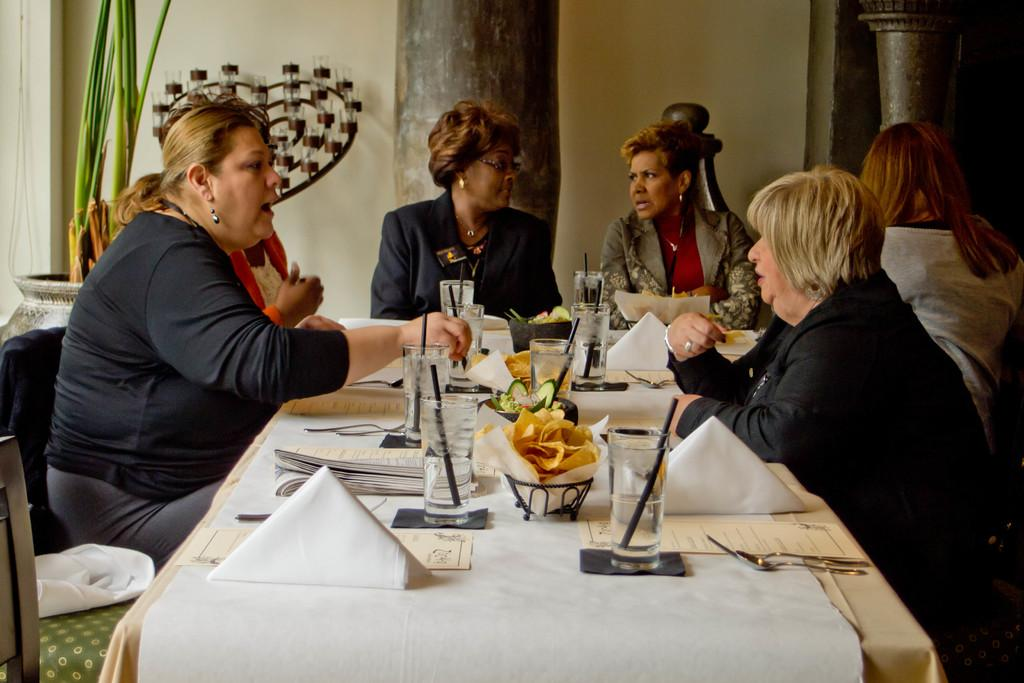What can be seen in the image? There is a group of women in the image. What are the women doing? The women are sitting. What is in front of the women? There is a table in front of the women. What is on the table? There is food, water glasses, and a food menu on the table. What type of scarecrow can be seen standing next to the table in the image? There is no scarecrow present in the image. What color is the brick used to build the table in the image? The image does not provide information about the color of the bricks used to build the table, nor does it mention a brick table. 